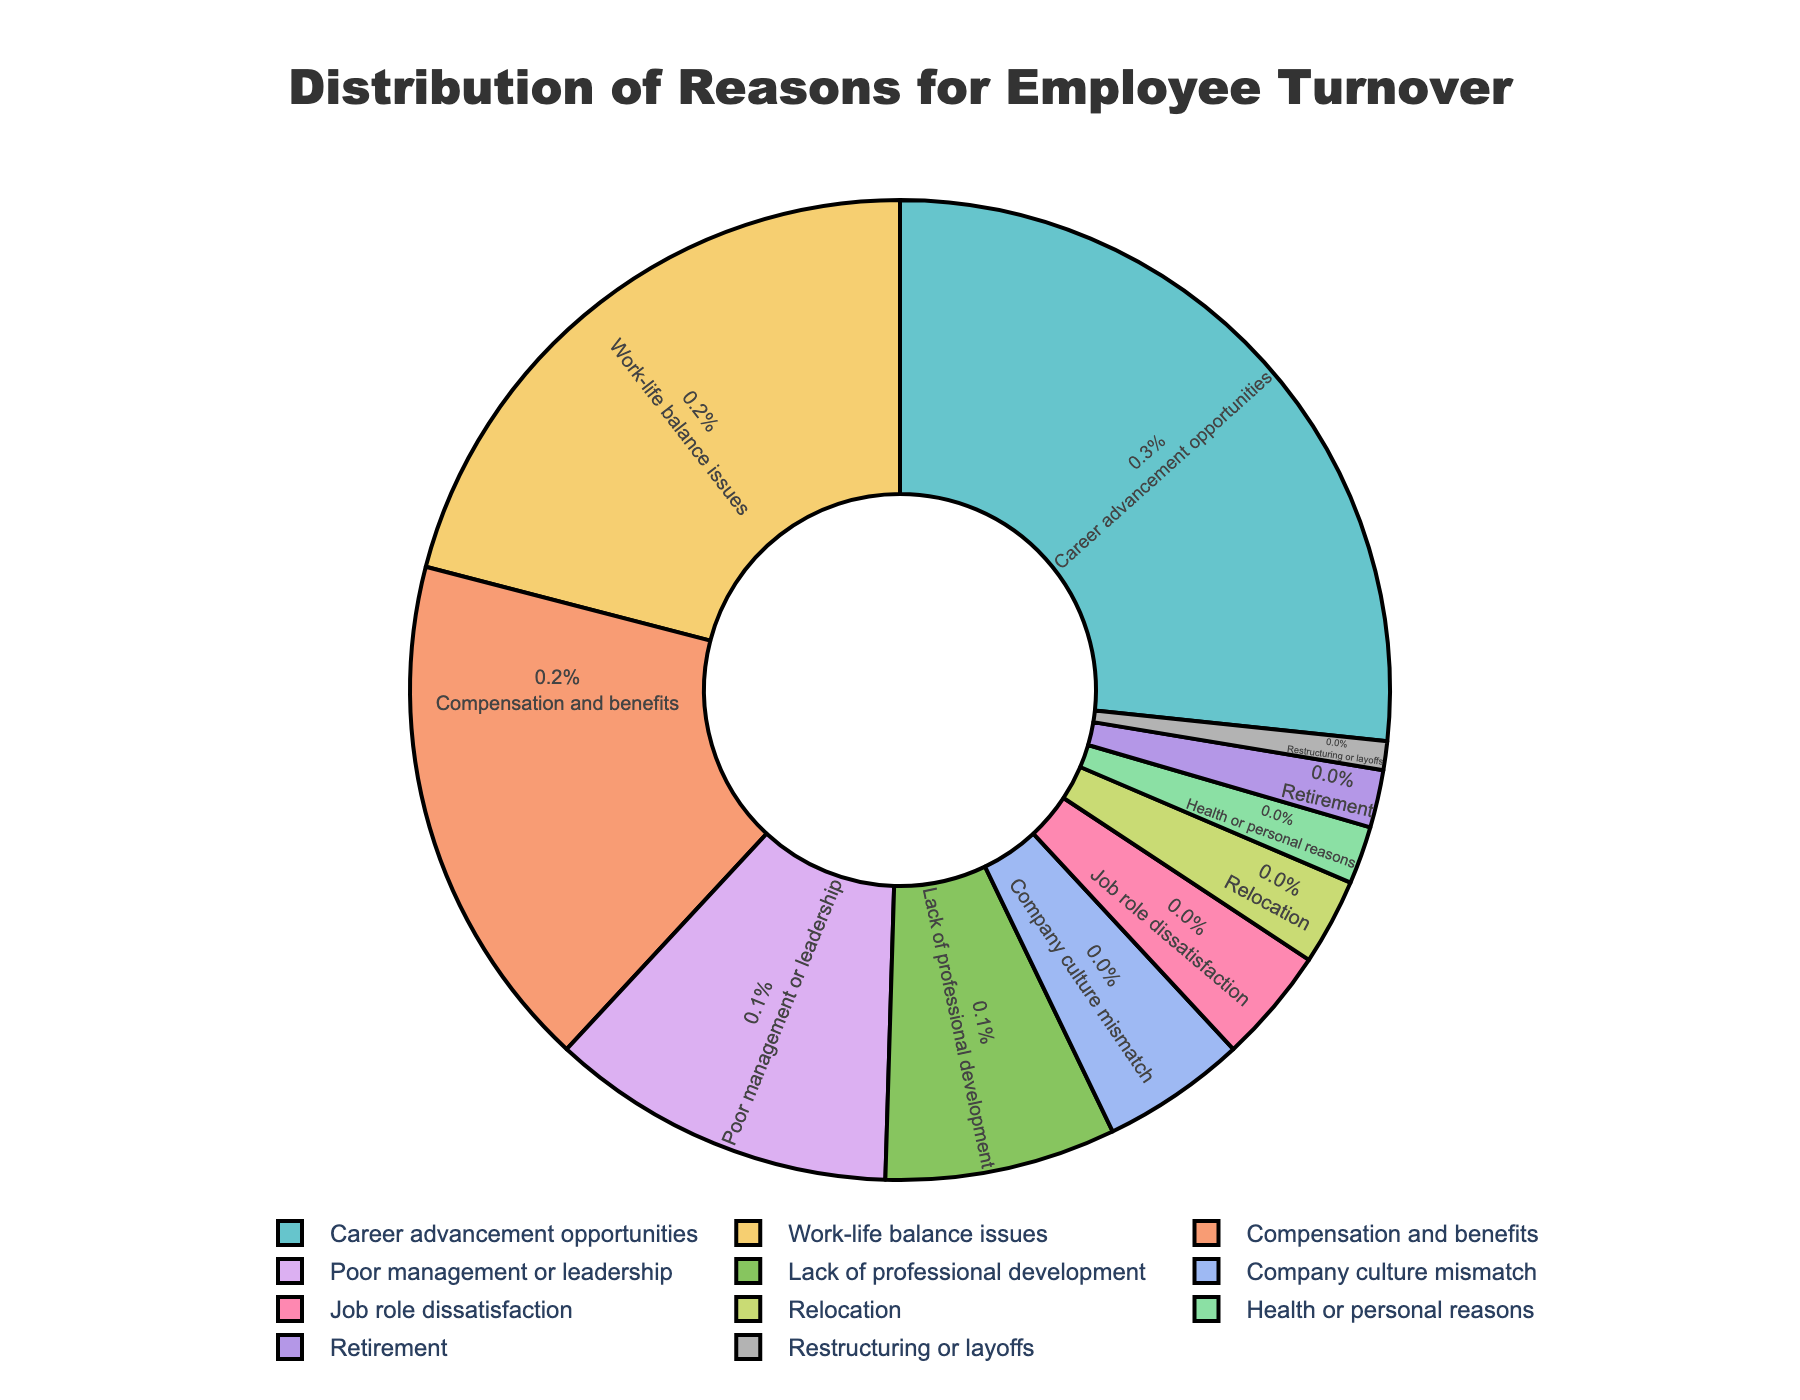Which reason accounts for the highest percentage of employee turnover? The largest segment on the pie chart corresponds to "Career advancement opportunities." Thus, it accounts for the highest percentage.
Answer: Career advancement opportunities What percentage of employee turnover is attributed to "Work-life balance issues" and "Compensation and benefits" combined? Add the percentages for both reasons: Work-life balance issues (22%) + Compensation and benefits (18%) = 40%.
Answer: 40% How much more significant is the percentage for "Career advancement opportunities" compared to "Lack of professional development"? Subtract the percentage of Lack of professional development from Career advancement opportunities: 28% - 8% = 20%.
Answer: 20% Which reason has the smallest percentage for employee turnover? The smallest segment on the pie chart corresponds to "Restructuring or layoffs," which is labeled as having 1%.
Answer: Restructuring or layoffs What is the total percentage of employee turnover attributed to health or personal reasons and retirement? Add the percentages for both reasons: Health or personal reasons (2%) + Retirement (2%) = 4%.
Answer: 4% Is the percentage of turnover due to "Company culture mismatch" greater than "Job role dissatisfaction"? Compare the percentages: Company culture mismatch (5%) is greater than Job role dissatisfaction (4%).
Answer: Yes What is the average percentage of employee turnover for the three least significant reasons? Sum the percentages of the three least significant reasons and divide by three: (Retirement 2% + Health or personal reasons 2% + Restructuring or layoffs 1%) / 3 = 5% / 3 = 1.67%.
Answer: 1.67% How many reasons account for at least 10% of employee turnover each? Identify and count the reasons with percentages at or above 10%: Career advancement opportunities (28%), Work-life balance issues (22%), Compensation and benefits (18%), and Poor management or leadership (12%). This totals to four reasons.
Answer: 4 What's the difference in percentage between "Compensation and benefits" and "Poor management or leadership"? Subtract the percentage of Poor management or leadership from Compensation and benefits: 18% - 12% = 6%.
Answer: 6% What percentage of turnover is due to factors not directly related to the job role or company, such as "Relocation," "Health or personal reasons," and "Retirement"? Sum the percentages for Relocation, Health or personal reasons, and Retirement: 3% + 2% + 2% = 7%.
Answer: 7% 